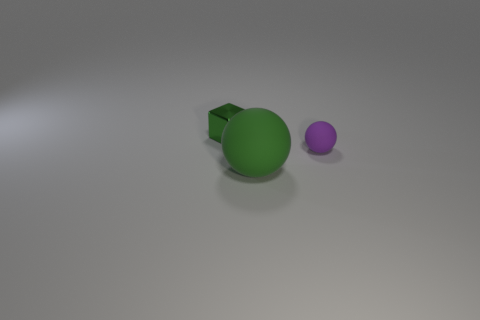Add 1 small green metal blocks. How many objects exist? 4 Subtract all spheres. How many objects are left? 1 Add 1 balls. How many balls exist? 3 Subtract 1 purple balls. How many objects are left? 2 Subtract all purple things. Subtract all tiny purple matte spheres. How many objects are left? 1 Add 1 matte things. How many matte things are left? 3 